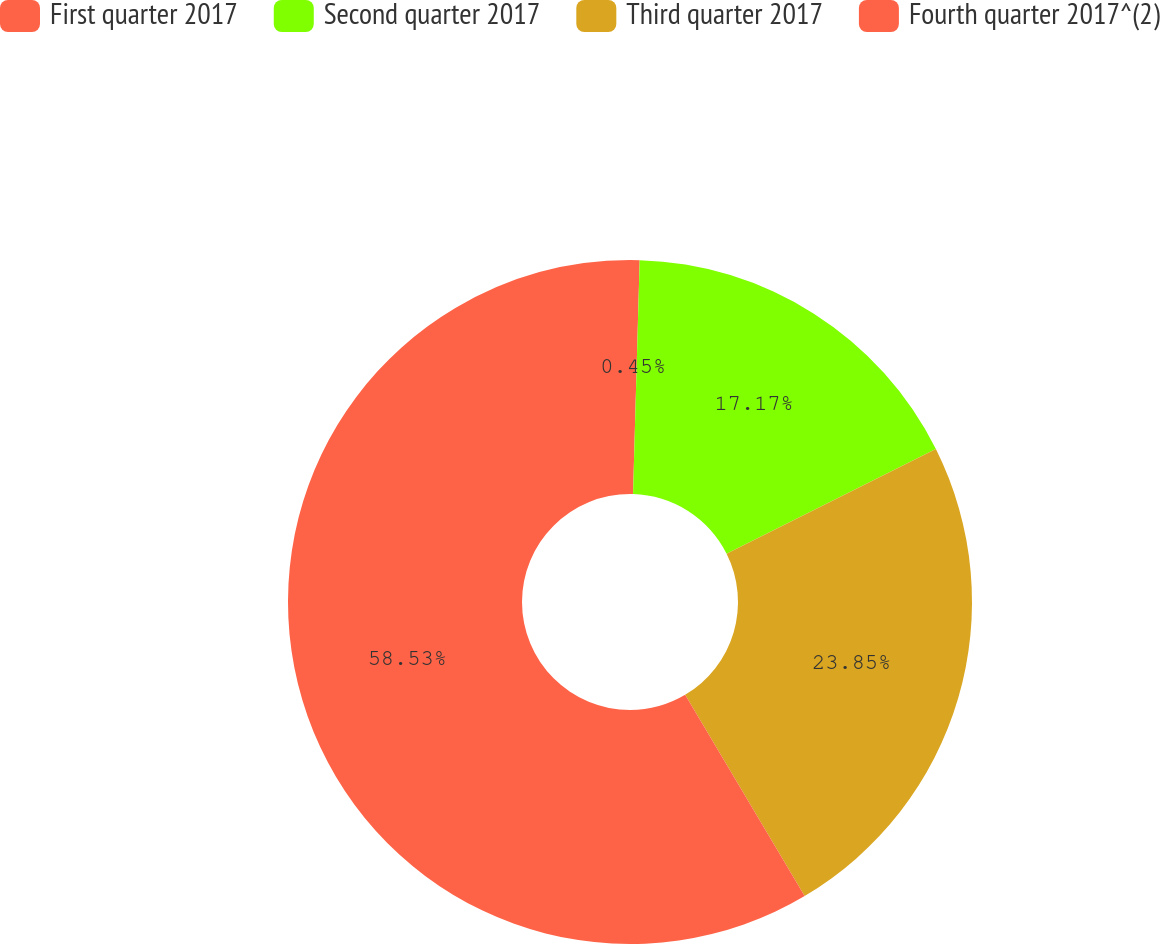Convert chart. <chart><loc_0><loc_0><loc_500><loc_500><pie_chart><fcel>First quarter 2017<fcel>Second quarter 2017<fcel>Third quarter 2017<fcel>Fourth quarter 2017^(2)<nl><fcel>0.45%<fcel>17.17%<fcel>23.85%<fcel>58.53%<nl></chart> 